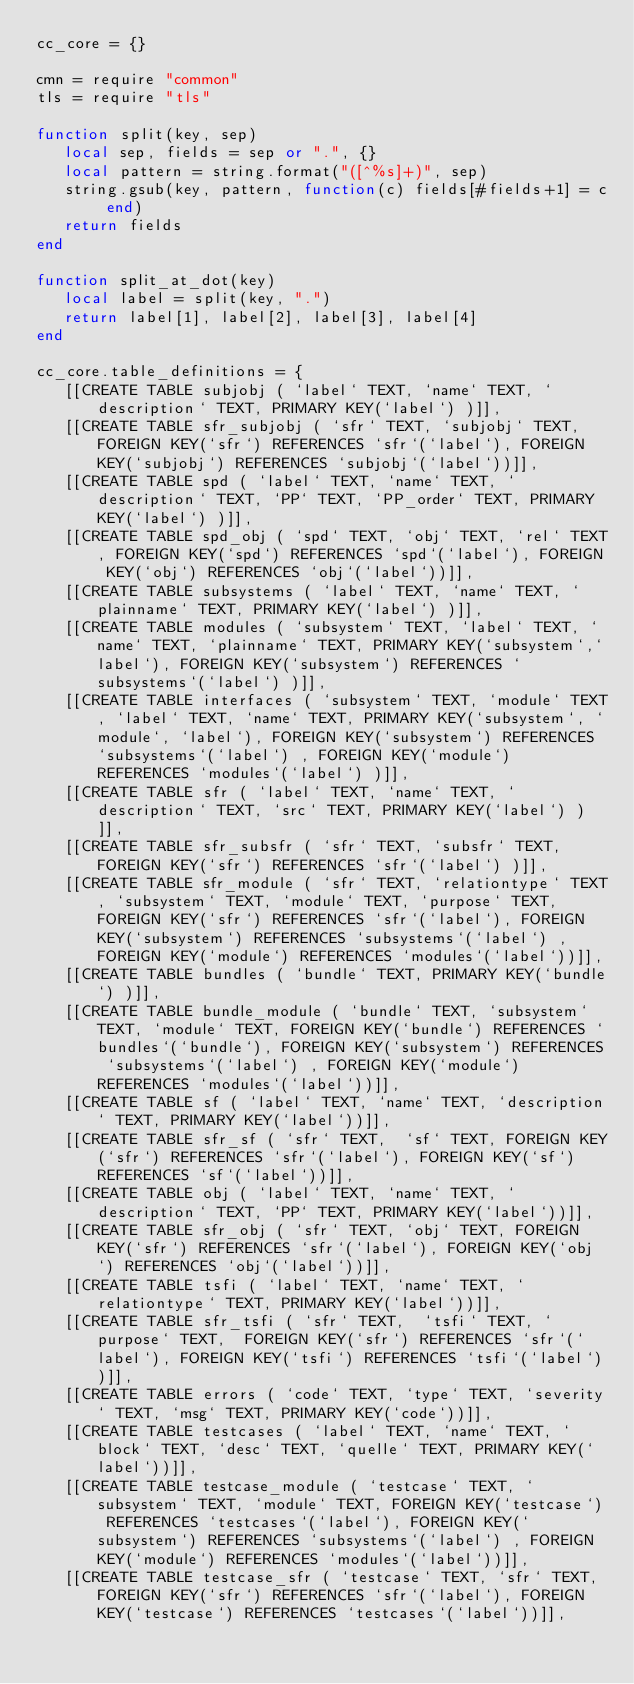Convert code to text. <code><loc_0><loc_0><loc_500><loc_500><_Lua_>cc_core = {}

cmn = require "common"
tls = require "tls"

function split(key, sep)
   local sep, fields = sep or ".", {}
   local pattern = string.format("([^%s]+)", sep)
   string.gsub(key, pattern, function(c) fields[#fields+1] = c end)
   return fields
end

function split_at_dot(key)
   local label = split(key, ".")
   return label[1], label[2], label[3], label[4]
end

cc_core.table_definitions = {
   [[CREATE TABLE subjobj ( `label` TEXT, `name` TEXT, `description` TEXT, PRIMARY KEY(`label`) )]],
   [[CREATE TABLE sfr_subjobj ( `sfr` TEXT, `subjobj` TEXT, FOREIGN KEY(`sfr`) REFERENCES `sfr`(`label`), FOREIGN KEY(`subjobj`) REFERENCES `subjobj`(`label`))]],
   [[CREATE TABLE spd ( `label` TEXT, `name` TEXT, `description` TEXT, `PP` TEXT, `PP_order` TEXT, PRIMARY KEY(`label`) )]],
   [[CREATE TABLE spd_obj ( `spd` TEXT, `obj` TEXT, `rel` TEXT, FOREIGN KEY(`spd`) REFERENCES `spd`(`label`), FOREIGN KEY(`obj`) REFERENCES `obj`(`label`))]],   
   [[CREATE TABLE subsystems ( `label` TEXT, `name` TEXT, `plainname` TEXT, PRIMARY KEY(`label`) )]],
   [[CREATE TABLE modules ( `subsystem` TEXT, `label` TEXT, `name` TEXT, `plainname` TEXT, PRIMARY KEY(`subsystem`,`label`), FOREIGN KEY(`subsystem`) REFERENCES `subsystems`(`label`) )]],
   [[CREATE TABLE interfaces ( `subsystem` TEXT, `module` TEXT, `label` TEXT, `name` TEXT, PRIMARY KEY(`subsystem`, `module`, `label`), FOREIGN KEY(`subsystem`) REFERENCES `subsystems`(`label`) , FOREIGN KEY(`module`) REFERENCES `modules`(`label`) )]],
   [[CREATE TABLE sfr ( `label` TEXT, `name` TEXT, `description` TEXT, `src` TEXT, PRIMARY KEY(`label`) )]],
   [[CREATE TABLE sfr_subsfr ( `sfr` TEXT, `subsfr` TEXT, FOREIGN KEY(`sfr`) REFERENCES `sfr`(`label`) )]],
   [[CREATE TABLE sfr_module ( `sfr` TEXT, `relationtype` TEXT, `subsystem` TEXT, `module` TEXT, `purpose` TEXT, FOREIGN KEY(`sfr`) REFERENCES `sfr`(`label`), FOREIGN KEY(`subsystem`) REFERENCES `subsystems`(`label`) , FOREIGN KEY(`module`) REFERENCES `modules`(`label`))]],
   [[CREATE TABLE bundles ( `bundle` TEXT, PRIMARY KEY(`bundle`) )]],
   [[CREATE TABLE bundle_module ( `bundle` TEXT, `subsystem` TEXT, `module` TEXT, FOREIGN KEY(`bundle`) REFERENCES `bundles`(`bundle`), FOREIGN KEY(`subsystem`) REFERENCES `subsystems`(`label`) , FOREIGN KEY(`module`) REFERENCES `modules`(`label`))]],
   [[CREATE TABLE sf ( `label` TEXT, `name` TEXT, `description` TEXT, PRIMARY KEY(`label`))]],
   [[CREATE TABLE sfr_sf ( `sfr` TEXT,  `sf` TEXT, FOREIGN KEY(`sfr`) REFERENCES `sfr`(`label`), FOREIGN KEY(`sf`) REFERENCES `sf`(`label`))]],
   [[CREATE TABLE obj ( `label` TEXT, `name` TEXT, `description` TEXT, `PP` TEXT, PRIMARY KEY(`label`))]],
   [[CREATE TABLE sfr_obj ( `sfr` TEXT, `obj` TEXT, FOREIGN KEY(`sfr`) REFERENCES `sfr`(`label`), FOREIGN KEY(`obj`) REFERENCES `obj`(`label`))]],
   [[CREATE TABLE tsfi ( `label` TEXT, `name` TEXT, `relationtype` TEXT, PRIMARY KEY(`label`))]],
   [[CREATE TABLE sfr_tsfi ( `sfr` TEXT,  `tsfi` TEXT, `purpose` TEXT,  FOREIGN KEY(`sfr`) REFERENCES `sfr`(`label`), FOREIGN KEY(`tsfi`) REFERENCES `tsfi`(`label`))]],
   [[CREATE TABLE errors ( `code` TEXT, `type` TEXT, `severity` TEXT, `msg` TEXT, PRIMARY KEY(`code`))]],
   [[CREATE TABLE testcases ( `label` TEXT, `name` TEXT, `block` TEXT, `desc` TEXT, `quelle` TEXT, PRIMARY KEY(`label`))]],
   [[CREATE TABLE testcase_module ( `testcase` TEXT, `subsystem` TEXT, `module` TEXT, FOREIGN KEY(`testcase`) REFERENCES `testcases`(`label`), FOREIGN KEY(`subsystem`) REFERENCES `subsystems`(`label`) , FOREIGN KEY(`module`) REFERENCES `modules`(`label`))]],
   [[CREATE TABLE testcase_sfr ( `testcase` TEXT, `sfr` TEXT, FOREIGN KEY(`sfr`) REFERENCES `sfr`(`label`), FOREIGN KEY(`testcase`) REFERENCES `testcases`(`label`))]],</code> 